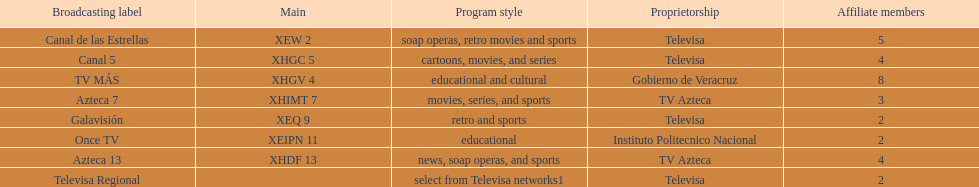What is the number of affiliates of canal de las estrellas. 5. 